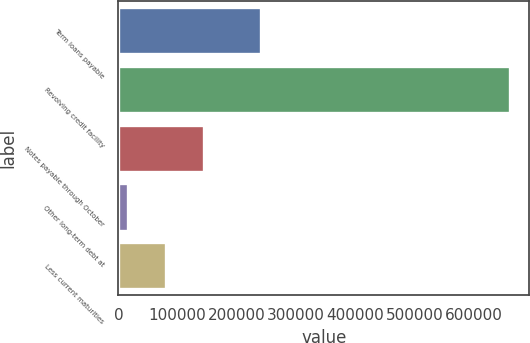Convert chart. <chart><loc_0><loc_0><loc_500><loc_500><bar_chart><fcel>Term loans payable<fcel>Revolving credit facility<fcel>Notes payable through October<fcel>Other long-term debt at<fcel>Less current maturities<nl><fcel>240625<fcel>660730<fcel>145252<fcel>16383<fcel>80817.7<nl></chart> 